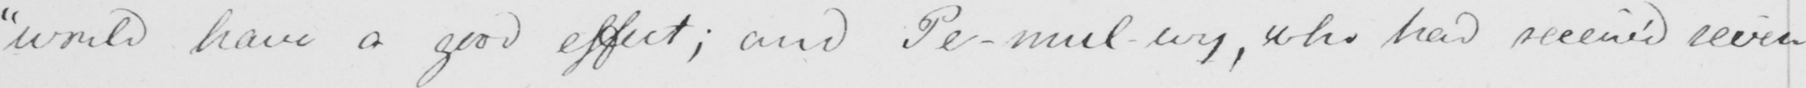What is written in this line of handwriting? " would have a good effect ; and presumably , who had received seven 